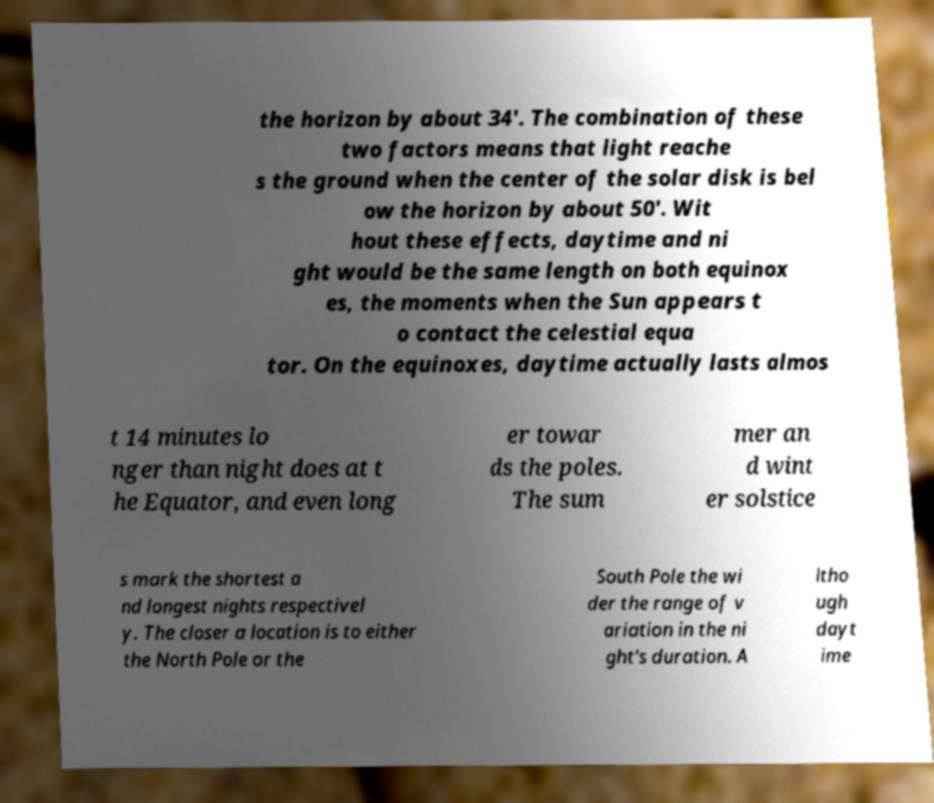For documentation purposes, I need the text within this image transcribed. Could you provide that? the horizon by about 34'. The combination of these two factors means that light reache s the ground when the center of the solar disk is bel ow the horizon by about 50'. Wit hout these effects, daytime and ni ght would be the same length on both equinox es, the moments when the Sun appears t o contact the celestial equa tor. On the equinoxes, daytime actually lasts almos t 14 minutes lo nger than night does at t he Equator, and even long er towar ds the poles. The sum mer an d wint er solstice s mark the shortest a nd longest nights respectivel y. The closer a location is to either the North Pole or the South Pole the wi der the range of v ariation in the ni ght's duration. A ltho ugh dayt ime 